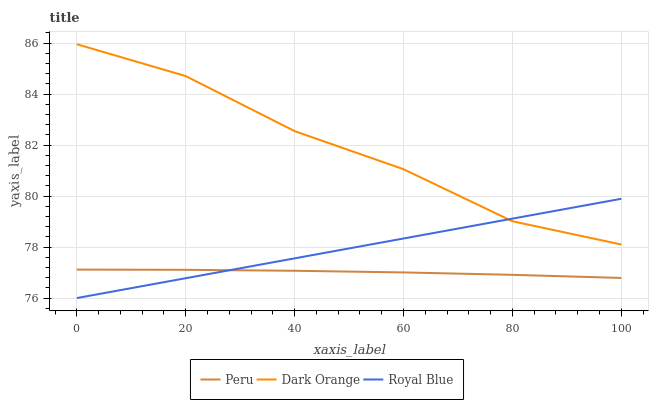Does Peru have the minimum area under the curve?
Answer yes or no. Yes. Does Dark Orange have the maximum area under the curve?
Answer yes or no. Yes. Does Royal Blue have the minimum area under the curve?
Answer yes or no. No. Does Royal Blue have the maximum area under the curve?
Answer yes or no. No. Is Royal Blue the smoothest?
Answer yes or no. Yes. Is Dark Orange the roughest?
Answer yes or no. Yes. Is Peru the smoothest?
Answer yes or no. No. Is Peru the roughest?
Answer yes or no. No. Does Peru have the lowest value?
Answer yes or no. No. Does Dark Orange have the highest value?
Answer yes or no. Yes. Does Royal Blue have the highest value?
Answer yes or no. No. Is Peru less than Dark Orange?
Answer yes or no. Yes. Is Dark Orange greater than Peru?
Answer yes or no. Yes. Does Peru intersect Royal Blue?
Answer yes or no. Yes. Is Peru less than Royal Blue?
Answer yes or no. No. Is Peru greater than Royal Blue?
Answer yes or no. No. Does Peru intersect Dark Orange?
Answer yes or no. No. 